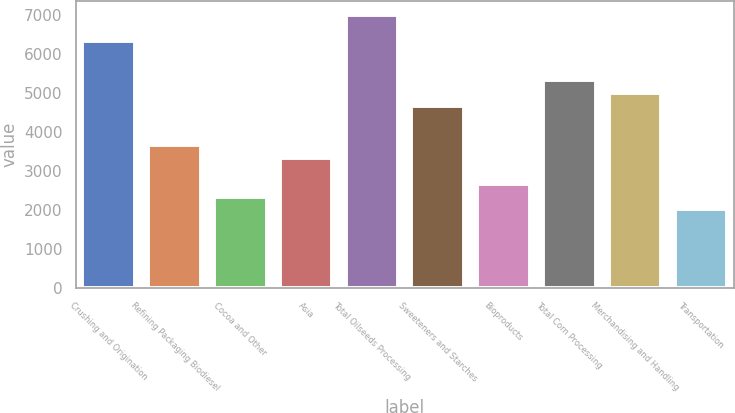Convert chart to OTSL. <chart><loc_0><loc_0><loc_500><loc_500><bar_chart><fcel>Crushing and Origination<fcel>Refining Packaging Biodiesel<fcel>Cocoa and Other<fcel>Asia<fcel>Total Oilseeds Processing<fcel>Sweeteners and Starches<fcel>Bioproducts<fcel>Total Corn Processing<fcel>Merchandising and Handling<fcel>Transportation<nl><fcel>6328.6<fcel>3669.4<fcel>2339.8<fcel>3337<fcel>6993.4<fcel>4666.6<fcel>2672.2<fcel>5331.4<fcel>4999<fcel>2007.4<nl></chart> 